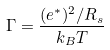<formula> <loc_0><loc_0><loc_500><loc_500>\Gamma = \frac { ( e ^ { * } ) ^ { 2 } / R _ { s } } { k _ { B } T }</formula> 